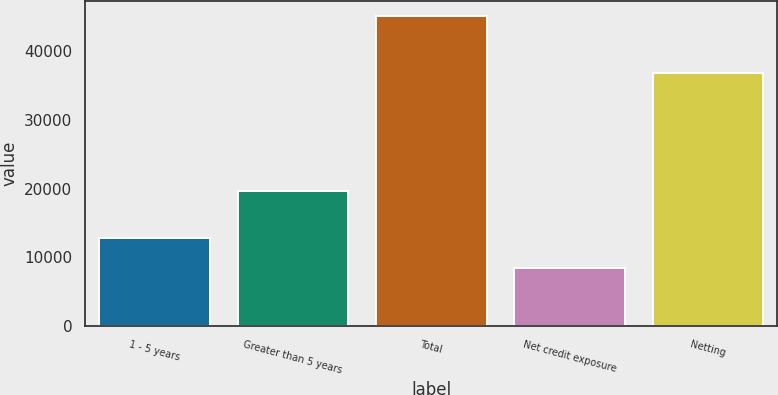Convert chart. <chart><loc_0><loc_0><loc_500><loc_500><bar_chart><fcel>1 - 5 years<fcel>Greater than 5 years<fcel>Total<fcel>Net credit exposure<fcel>Netting<nl><fcel>12814<fcel>19682<fcel>45091<fcel>8401<fcel>36847<nl></chart> 